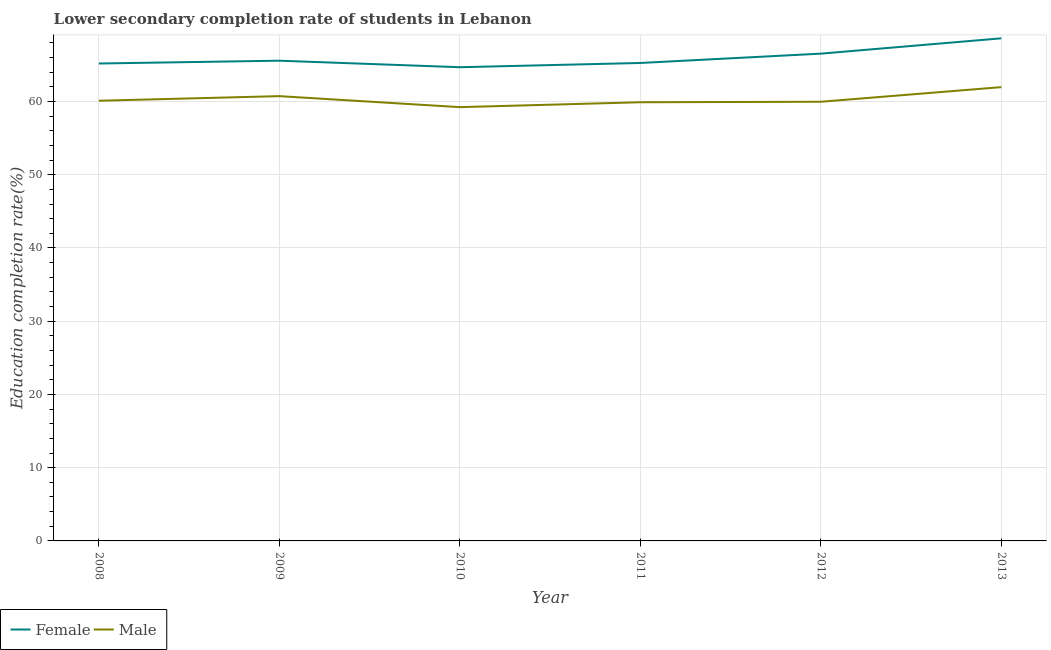How many different coloured lines are there?
Provide a succinct answer. 2. Is the number of lines equal to the number of legend labels?
Keep it short and to the point. Yes. What is the education completion rate of female students in 2011?
Ensure brevity in your answer.  65.26. Across all years, what is the maximum education completion rate of female students?
Offer a very short reply. 68.62. Across all years, what is the minimum education completion rate of female students?
Your answer should be very brief. 64.68. In which year was the education completion rate of male students maximum?
Your answer should be very brief. 2013. In which year was the education completion rate of male students minimum?
Give a very brief answer. 2010. What is the total education completion rate of male students in the graph?
Your answer should be very brief. 361.88. What is the difference between the education completion rate of female students in 2008 and that in 2012?
Offer a terse response. -1.35. What is the difference between the education completion rate of male students in 2013 and the education completion rate of female students in 2010?
Your answer should be very brief. -2.72. What is the average education completion rate of male students per year?
Offer a terse response. 60.31. In the year 2011, what is the difference between the education completion rate of female students and education completion rate of male students?
Give a very brief answer. 5.36. What is the ratio of the education completion rate of female students in 2008 to that in 2013?
Make the answer very short. 0.95. Is the difference between the education completion rate of female students in 2008 and 2011 greater than the difference between the education completion rate of male students in 2008 and 2011?
Offer a terse response. No. What is the difference between the highest and the second highest education completion rate of male students?
Provide a short and direct response. 1.23. What is the difference between the highest and the lowest education completion rate of male students?
Ensure brevity in your answer.  2.73. Is the education completion rate of female students strictly greater than the education completion rate of male students over the years?
Your answer should be compact. Yes. Are the values on the major ticks of Y-axis written in scientific E-notation?
Provide a short and direct response. No. Does the graph contain grids?
Offer a very short reply. Yes. How are the legend labels stacked?
Make the answer very short. Horizontal. What is the title of the graph?
Ensure brevity in your answer.  Lower secondary completion rate of students in Lebanon. What is the label or title of the X-axis?
Your answer should be compact. Year. What is the label or title of the Y-axis?
Your answer should be very brief. Education completion rate(%). What is the Education completion rate(%) of Female in 2008?
Give a very brief answer. 65.19. What is the Education completion rate(%) of Male in 2008?
Make the answer very short. 60.1. What is the Education completion rate(%) of Female in 2009?
Offer a very short reply. 65.57. What is the Education completion rate(%) in Male in 2009?
Your answer should be compact. 60.73. What is the Education completion rate(%) in Female in 2010?
Provide a succinct answer. 64.68. What is the Education completion rate(%) in Male in 2010?
Provide a succinct answer. 59.23. What is the Education completion rate(%) of Female in 2011?
Provide a short and direct response. 65.26. What is the Education completion rate(%) of Male in 2011?
Your response must be concise. 59.9. What is the Education completion rate(%) of Female in 2012?
Provide a short and direct response. 66.53. What is the Education completion rate(%) in Male in 2012?
Provide a succinct answer. 59.96. What is the Education completion rate(%) in Female in 2013?
Keep it short and to the point. 68.62. What is the Education completion rate(%) in Male in 2013?
Give a very brief answer. 61.96. Across all years, what is the maximum Education completion rate(%) of Female?
Your response must be concise. 68.62. Across all years, what is the maximum Education completion rate(%) of Male?
Make the answer very short. 61.96. Across all years, what is the minimum Education completion rate(%) in Female?
Provide a short and direct response. 64.68. Across all years, what is the minimum Education completion rate(%) in Male?
Give a very brief answer. 59.23. What is the total Education completion rate(%) in Female in the graph?
Provide a succinct answer. 395.85. What is the total Education completion rate(%) of Male in the graph?
Give a very brief answer. 361.88. What is the difference between the Education completion rate(%) of Female in 2008 and that in 2009?
Provide a short and direct response. -0.38. What is the difference between the Education completion rate(%) of Male in 2008 and that in 2009?
Ensure brevity in your answer.  -0.63. What is the difference between the Education completion rate(%) of Female in 2008 and that in 2010?
Provide a short and direct response. 0.51. What is the difference between the Education completion rate(%) in Male in 2008 and that in 2010?
Provide a succinct answer. 0.87. What is the difference between the Education completion rate(%) in Female in 2008 and that in 2011?
Make the answer very short. -0.07. What is the difference between the Education completion rate(%) of Male in 2008 and that in 2011?
Provide a short and direct response. 0.21. What is the difference between the Education completion rate(%) in Female in 2008 and that in 2012?
Offer a terse response. -1.35. What is the difference between the Education completion rate(%) of Male in 2008 and that in 2012?
Ensure brevity in your answer.  0.14. What is the difference between the Education completion rate(%) in Female in 2008 and that in 2013?
Offer a terse response. -3.44. What is the difference between the Education completion rate(%) of Male in 2008 and that in 2013?
Give a very brief answer. -1.86. What is the difference between the Education completion rate(%) of Female in 2009 and that in 2010?
Keep it short and to the point. 0.89. What is the difference between the Education completion rate(%) in Male in 2009 and that in 2010?
Ensure brevity in your answer.  1.5. What is the difference between the Education completion rate(%) of Female in 2009 and that in 2011?
Provide a short and direct response. 0.31. What is the difference between the Education completion rate(%) in Male in 2009 and that in 2011?
Your answer should be very brief. 0.83. What is the difference between the Education completion rate(%) in Female in 2009 and that in 2012?
Offer a terse response. -0.96. What is the difference between the Education completion rate(%) in Male in 2009 and that in 2012?
Ensure brevity in your answer.  0.77. What is the difference between the Education completion rate(%) in Female in 2009 and that in 2013?
Offer a very short reply. -3.06. What is the difference between the Education completion rate(%) of Male in 2009 and that in 2013?
Your response must be concise. -1.23. What is the difference between the Education completion rate(%) of Female in 2010 and that in 2011?
Give a very brief answer. -0.58. What is the difference between the Education completion rate(%) in Male in 2010 and that in 2011?
Your answer should be very brief. -0.67. What is the difference between the Education completion rate(%) in Female in 2010 and that in 2012?
Give a very brief answer. -1.85. What is the difference between the Education completion rate(%) of Male in 2010 and that in 2012?
Make the answer very short. -0.74. What is the difference between the Education completion rate(%) in Female in 2010 and that in 2013?
Provide a succinct answer. -3.95. What is the difference between the Education completion rate(%) in Male in 2010 and that in 2013?
Give a very brief answer. -2.73. What is the difference between the Education completion rate(%) of Female in 2011 and that in 2012?
Provide a succinct answer. -1.27. What is the difference between the Education completion rate(%) of Male in 2011 and that in 2012?
Your answer should be very brief. -0.07. What is the difference between the Education completion rate(%) in Female in 2011 and that in 2013?
Your answer should be compact. -3.37. What is the difference between the Education completion rate(%) of Male in 2011 and that in 2013?
Provide a succinct answer. -2.06. What is the difference between the Education completion rate(%) of Female in 2012 and that in 2013?
Offer a very short reply. -2.09. What is the difference between the Education completion rate(%) of Male in 2012 and that in 2013?
Your answer should be very brief. -2. What is the difference between the Education completion rate(%) of Female in 2008 and the Education completion rate(%) of Male in 2009?
Make the answer very short. 4.46. What is the difference between the Education completion rate(%) in Female in 2008 and the Education completion rate(%) in Male in 2010?
Offer a terse response. 5.96. What is the difference between the Education completion rate(%) of Female in 2008 and the Education completion rate(%) of Male in 2011?
Keep it short and to the point. 5.29. What is the difference between the Education completion rate(%) in Female in 2008 and the Education completion rate(%) in Male in 2012?
Your answer should be very brief. 5.22. What is the difference between the Education completion rate(%) in Female in 2008 and the Education completion rate(%) in Male in 2013?
Give a very brief answer. 3.23. What is the difference between the Education completion rate(%) of Female in 2009 and the Education completion rate(%) of Male in 2010?
Ensure brevity in your answer.  6.34. What is the difference between the Education completion rate(%) in Female in 2009 and the Education completion rate(%) in Male in 2011?
Give a very brief answer. 5.67. What is the difference between the Education completion rate(%) of Female in 2009 and the Education completion rate(%) of Male in 2012?
Give a very brief answer. 5.61. What is the difference between the Education completion rate(%) of Female in 2009 and the Education completion rate(%) of Male in 2013?
Give a very brief answer. 3.61. What is the difference between the Education completion rate(%) of Female in 2010 and the Education completion rate(%) of Male in 2011?
Give a very brief answer. 4.78. What is the difference between the Education completion rate(%) of Female in 2010 and the Education completion rate(%) of Male in 2012?
Offer a very short reply. 4.71. What is the difference between the Education completion rate(%) in Female in 2010 and the Education completion rate(%) in Male in 2013?
Offer a very short reply. 2.72. What is the difference between the Education completion rate(%) of Female in 2011 and the Education completion rate(%) of Male in 2012?
Your answer should be compact. 5.29. What is the difference between the Education completion rate(%) of Female in 2011 and the Education completion rate(%) of Male in 2013?
Offer a terse response. 3.3. What is the difference between the Education completion rate(%) of Female in 2012 and the Education completion rate(%) of Male in 2013?
Your response must be concise. 4.57. What is the average Education completion rate(%) in Female per year?
Provide a short and direct response. 65.98. What is the average Education completion rate(%) in Male per year?
Your response must be concise. 60.31. In the year 2008, what is the difference between the Education completion rate(%) in Female and Education completion rate(%) in Male?
Keep it short and to the point. 5.08. In the year 2009, what is the difference between the Education completion rate(%) in Female and Education completion rate(%) in Male?
Offer a terse response. 4.84. In the year 2010, what is the difference between the Education completion rate(%) of Female and Education completion rate(%) of Male?
Offer a very short reply. 5.45. In the year 2011, what is the difference between the Education completion rate(%) of Female and Education completion rate(%) of Male?
Your answer should be very brief. 5.36. In the year 2012, what is the difference between the Education completion rate(%) of Female and Education completion rate(%) of Male?
Make the answer very short. 6.57. In the year 2013, what is the difference between the Education completion rate(%) in Female and Education completion rate(%) in Male?
Keep it short and to the point. 6.67. What is the ratio of the Education completion rate(%) in Female in 2008 to that in 2009?
Ensure brevity in your answer.  0.99. What is the ratio of the Education completion rate(%) in Female in 2008 to that in 2010?
Offer a very short reply. 1.01. What is the ratio of the Education completion rate(%) of Male in 2008 to that in 2010?
Provide a short and direct response. 1.01. What is the ratio of the Education completion rate(%) in Female in 2008 to that in 2011?
Your answer should be compact. 1. What is the ratio of the Education completion rate(%) in Female in 2008 to that in 2012?
Provide a succinct answer. 0.98. What is the ratio of the Education completion rate(%) of Female in 2008 to that in 2013?
Ensure brevity in your answer.  0.95. What is the ratio of the Education completion rate(%) in Male in 2008 to that in 2013?
Make the answer very short. 0.97. What is the ratio of the Education completion rate(%) of Female in 2009 to that in 2010?
Your answer should be very brief. 1.01. What is the ratio of the Education completion rate(%) in Male in 2009 to that in 2010?
Offer a terse response. 1.03. What is the ratio of the Education completion rate(%) in Male in 2009 to that in 2011?
Offer a very short reply. 1.01. What is the ratio of the Education completion rate(%) of Female in 2009 to that in 2012?
Make the answer very short. 0.99. What is the ratio of the Education completion rate(%) of Male in 2009 to that in 2012?
Make the answer very short. 1.01. What is the ratio of the Education completion rate(%) of Female in 2009 to that in 2013?
Your answer should be very brief. 0.96. What is the ratio of the Education completion rate(%) of Male in 2009 to that in 2013?
Offer a very short reply. 0.98. What is the ratio of the Education completion rate(%) in Female in 2010 to that in 2011?
Keep it short and to the point. 0.99. What is the ratio of the Education completion rate(%) in Female in 2010 to that in 2012?
Provide a short and direct response. 0.97. What is the ratio of the Education completion rate(%) in Female in 2010 to that in 2013?
Provide a short and direct response. 0.94. What is the ratio of the Education completion rate(%) in Male in 2010 to that in 2013?
Ensure brevity in your answer.  0.96. What is the ratio of the Education completion rate(%) in Female in 2011 to that in 2012?
Your answer should be compact. 0.98. What is the ratio of the Education completion rate(%) in Male in 2011 to that in 2012?
Keep it short and to the point. 1. What is the ratio of the Education completion rate(%) of Female in 2011 to that in 2013?
Offer a terse response. 0.95. What is the ratio of the Education completion rate(%) in Male in 2011 to that in 2013?
Offer a terse response. 0.97. What is the ratio of the Education completion rate(%) in Female in 2012 to that in 2013?
Offer a very short reply. 0.97. What is the ratio of the Education completion rate(%) of Male in 2012 to that in 2013?
Provide a succinct answer. 0.97. What is the difference between the highest and the second highest Education completion rate(%) in Female?
Your answer should be very brief. 2.09. What is the difference between the highest and the second highest Education completion rate(%) in Male?
Provide a short and direct response. 1.23. What is the difference between the highest and the lowest Education completion rate(%) in Female?
Ensure brevity in your answer.  3.95. What is the difference between the highest and the lowest Education completion rate(%) in Male?
Offer a very short reply. 2.73. 